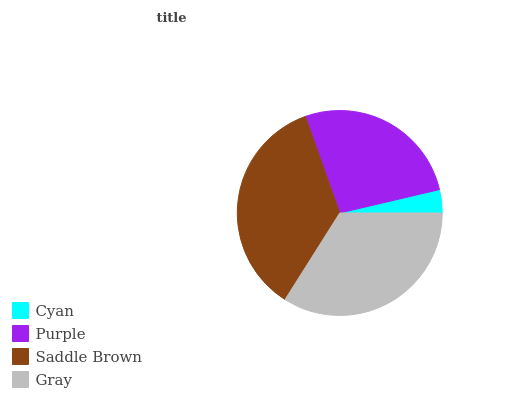Is Cyan the minimum?
Answer yes or no. Yes. Is Saddle Brown the maximum?
Answer yes or no. Yes. Is Purple the minimum?
Answer yes or no. No. Is Purple the maximum?
Answer yes or no. No. Is Purple greater than Cyan?
Answer yes or no. Yes. Is Cyan less than Purple?
Answer yes or no. Yes. Is Cyan greater than Purple?
Answer yes or no. No. Is Purple less than Cyan?
Answer yes or no. No. Is Gray the high median?
Answer yes or no. Yes. Is Purple the low median?
Answer yes or no. Yes. Is Purple the high median?
Answer yes or no. No. Is Cyan the low median?
Answer yes or no. No. 